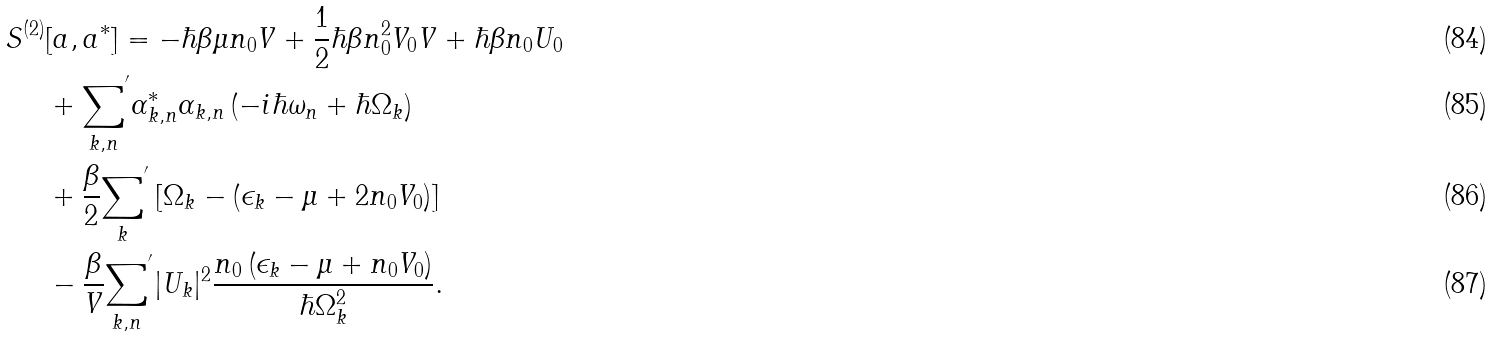Convert formula to latex. <formula><loc_0><loc_0><loc_500><loc_500>S ^ { ( 2 ) } & [ a , a ^ { * } ] = - \hbar { \beta } \mu n _ { 0 } V + \frac { 1 } { 2 } \hbar { \beta } n _ { 0 } ^ { 2 } V _ { 0 } V + \hbar { \beta } n _ { 0 } U _ { 0 } \\ & + { { \sum _ { { k } , n } } } ^ { ^ { \prime } } \alpha _ { { k } , n } ^ { * } \alpha _ { { k } , n } \left ( - i \hbar { \omega } _ { n } + \hbar { \Omega } _ { k } \right ) \\ & + \frac { \beta } { 2 } { { \sum _ { k } } } ^ { ^ { \prime } } \left [ \Omega _ { k } - \left ( \epsilon _ { k } - \mu + 2 n _ { 0 } V _ { 0 } \right ) \right ] \\ & - \frac { \beta } { V } { { \sum _ { { k } , n } } } ^ { ^ { \prime } } | U _ { k } | ^ { 2 } \frac { n _ { 0 } \left ( \epsilon _ { k } - \mu + n _ { 0 } V _ { 0 } \right ) } { \hbar { \Omega } _ { k } ^ { 2 } } .</formula> 